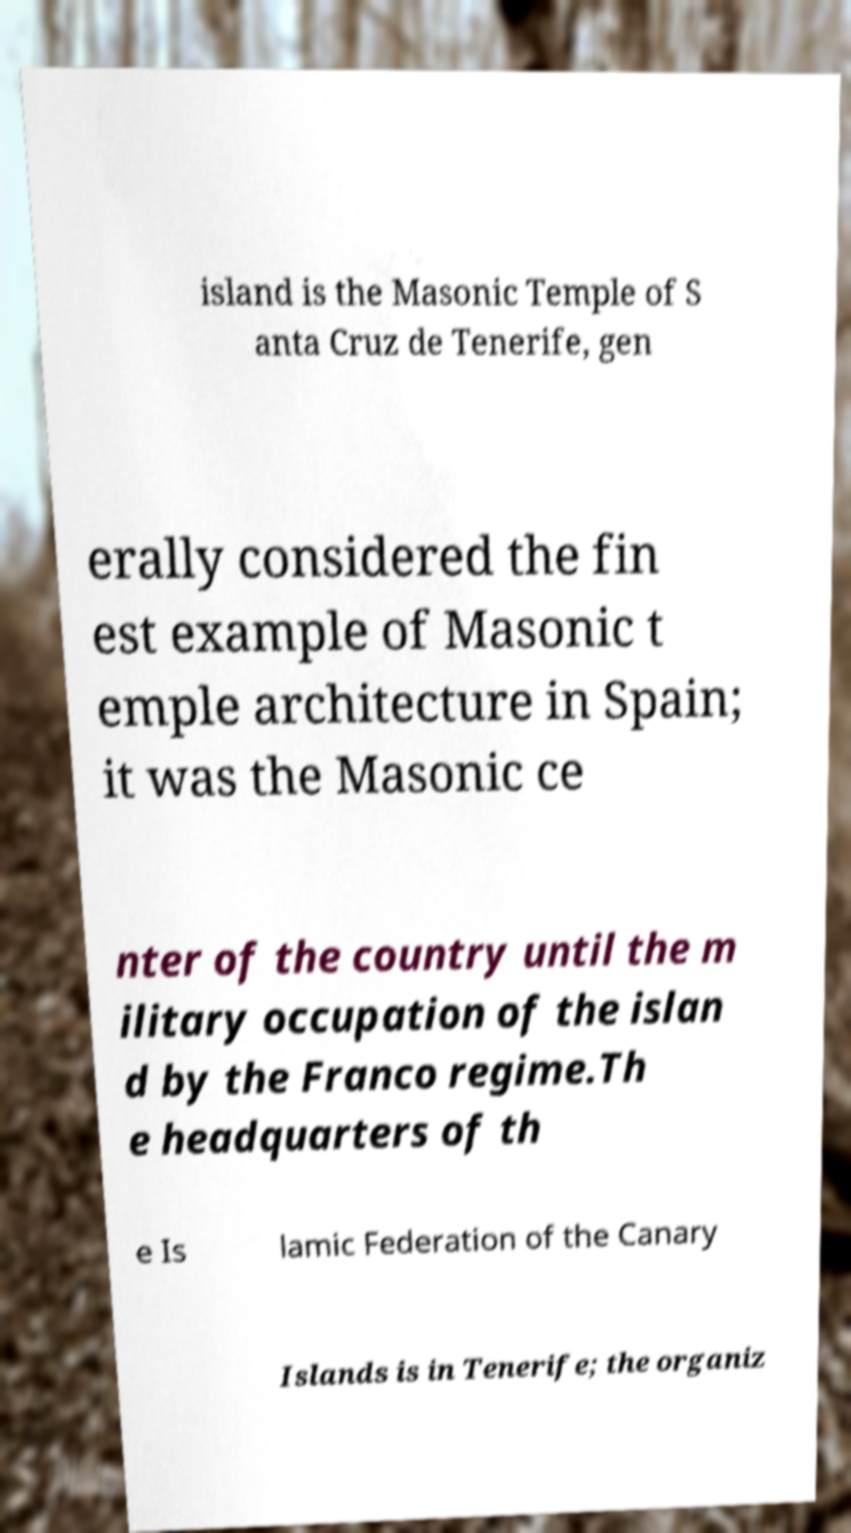Can you accurately transcribe the text from the provided image for me? island is the Masonic Temple of S anta Cruz de Tenerife, gen erally considered the fin est example of Masonic t emple architecture in Spain; it was the Masonic ce nter of the country until the m ilitary occupation of the islan d by the Franco regime.Th e headquarters of th e Is lamic Federation of the Canary Islands is in Tenerife; the organiz 